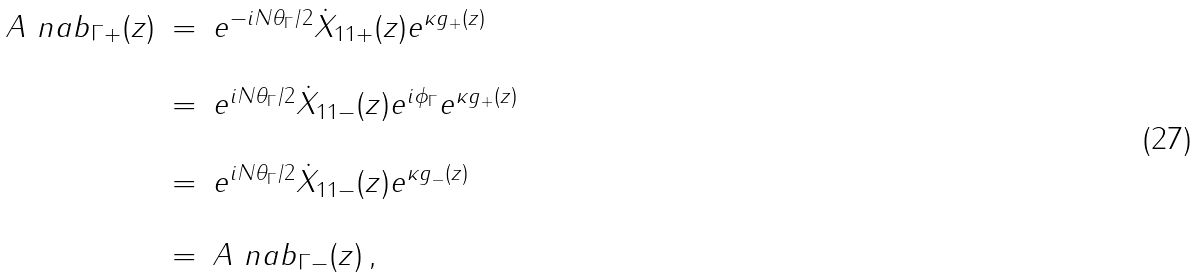<formula> <loc_0><loc_0><loc_500><loc_500>\begin{array} { r c l } A ^ { \ } n a b _ { \Gamma + } ( z ) & = & e ^ { - i N \theta _ { \Gamma } / 2 } \dot { X } _ { 1 1 + } ( z ) e ^ { \kappa g _ { + } ( z ) } \\ \\ & = & e ^ { i N \theta _ { \Gamma } / 2 } \dot { X } _ { 1 1 - } ( z ) e ^ { i \phi _ { \Gamma } } e ^ { \kappa g _ { + } ( z ) } \\ \\ & = & e ^ { i N \theta _ { \Gamma } / 2 } \dot { X } _ { 1 1 - } ( z ) e ^ { \kappa g _ { - } ( z ) } \\ \\ & = & A ^ { \ } n a b _ { \Gamma - } ( z ) \, , \end{array}</formula> 